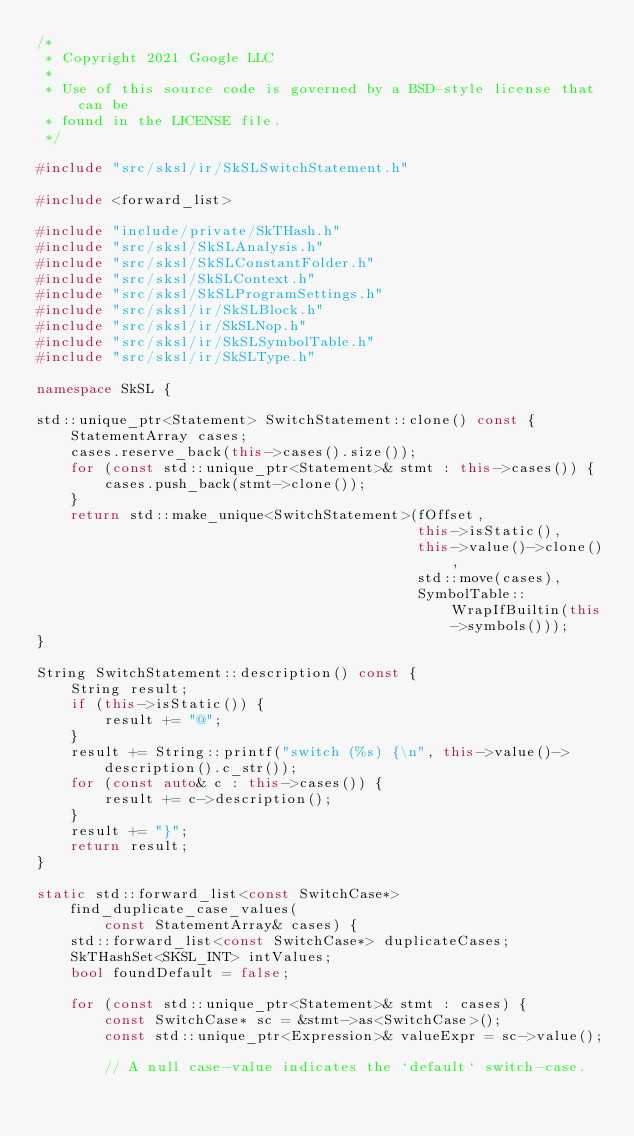<code> <loc_0><loc_0><loc_500><loc_500><_C++_>/*
 * Copyright 2021 Google LLC
 *
 * Use of this source code is governed by a BSD-style license that can be
 * found in the LICENSE file.
 */

#include "src/sksl/ir/SkSLSwitchStatement.h"

#include <forward_list>

#include "include/private/SkTHash.h"
#include "src/sksl/SkSLAnalysis.h"
#include "src/sksl/SkSLConstantFolder.h"
#include "src/sksl/SkSLContext.h"
#include "src/sksl/SkSLProgramSettings.h"
#include "src/sksl/ir/SkSLBlock.h"
#include "src/sksl/ir/SkSLNop.h"
#include "src/sksl/ir/SkSLSymbolTable.h"
#include "src/sksl/ir/SkSLType.h"

namespace SkSL {

std::unique_ptr<Statement> SwitchStatement::clone() const {
    StatementArray cases;
    cases.reserve_back(this->cases().size());
    for (const std::unique_ptr<Statement>& stmt : this->cases()) {
        cases.push_back(stmt->clone());
    }
    return std::make_unique<SwitchStatement>(fOffset,
                                             this->isStatic(),
                                             this->value()->clone(),
                                             std::move(cases),
                                             SymbolTable::WrapIfBuiltin(this->symbols()));
}

String SwitchStatement::description() const {
    String result;
    if (this->isStatic()) {
        result += "@";
    }
    result += String::printf("switch (%s) {\n", this->value()->description().c_str());
    for (const auto& c : this->cases()) {
        result += c->description();
    }
    result += "}";
    return result;
}

static std::forward_list<const SwitchCase*> find_duplicate_case_values(
        const StatementArray& cases) {
    std::forward_list<const SwitchCase*> duplicateCases;
    SkTHashSet<SKSL_INT> intValues;
    bool foundDefault = false;

    for (const std::unique_ptr<Statement>& stmt : cases) {
        const SwitchCase* sc = &stmt->as<SwitchCase>();
        const std::unique_ptr<Expression>& valueExpr = sc->value();

        // A null case-value indicates the `default` switch-case.</code> 